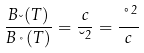<formula> <loc_0><loc_0><loc_500><loc_500>\frac { B _ { \lambda } ( T ) } { B _ { \nu } ( T ) } = \frac { c } { \lambda ^ { 2 } } = \frac { \nu ^ { 2 } } { c }</formula> 